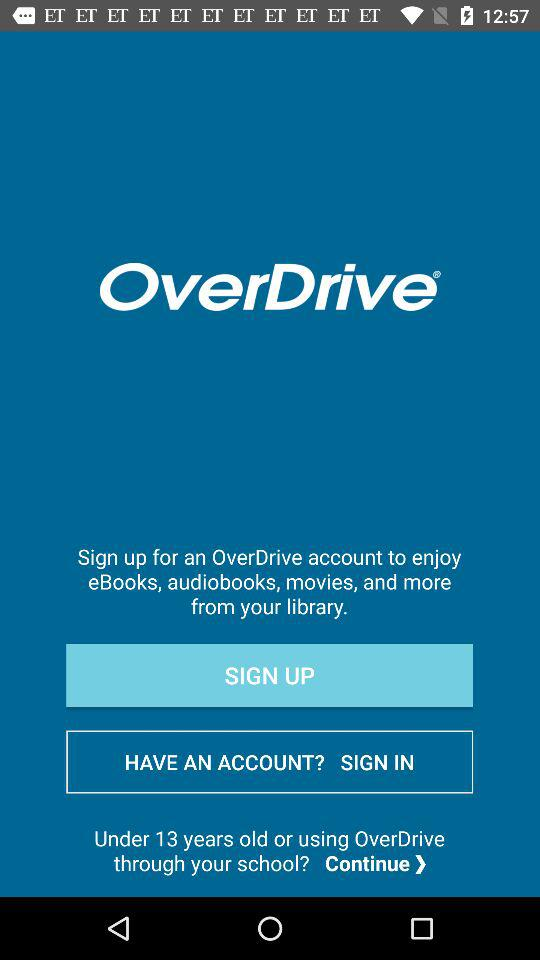What is the application name? The application name is "OverDrive". 